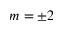<formula> <loc_0><loc_0><loc_500><loc_500>m = \pm 2</formula> 